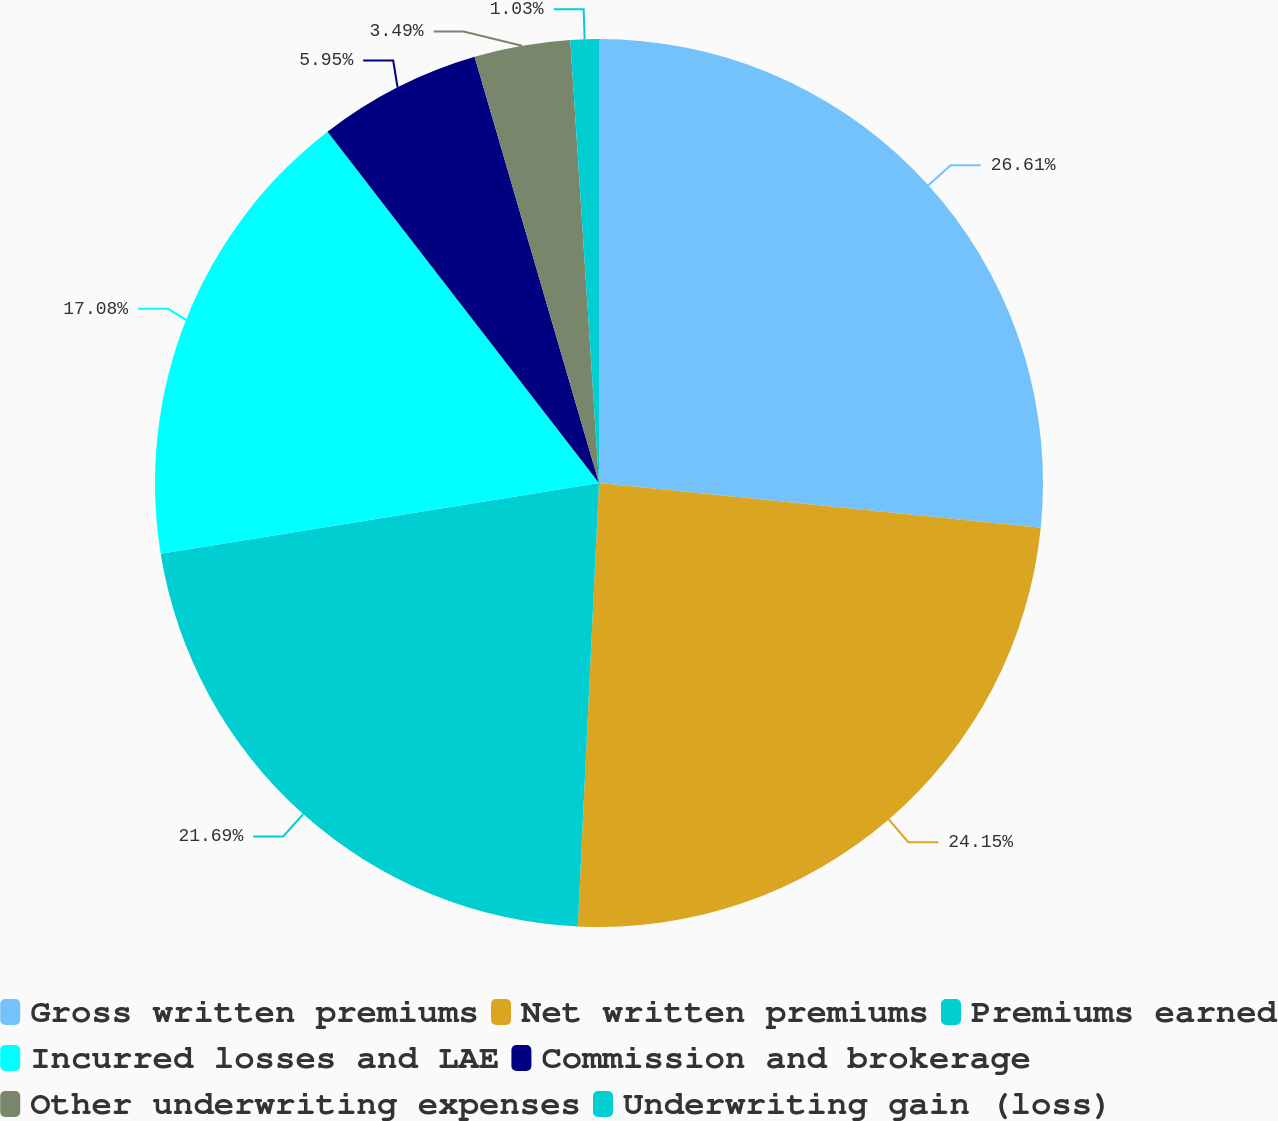Convert chart to OTSL. <chart><loc_0><loc_0><loc_500><loc_500><pie_chart><fcel>Gross written premiums<fcel>Net written premiums<fcel>Premiums earned<fcel>Incurred losses and LAE<fcel>Commission and brokerage<fcel>Other underwriting expenses<fcel>Underwriting gain (loss)<nl><fcel>26.61%<fcel>24.15%<fcel>21.69%<fcel>17.08%<fcel>5.95%<fcel>3.49%<fcel>1.03%<nl></chart> 